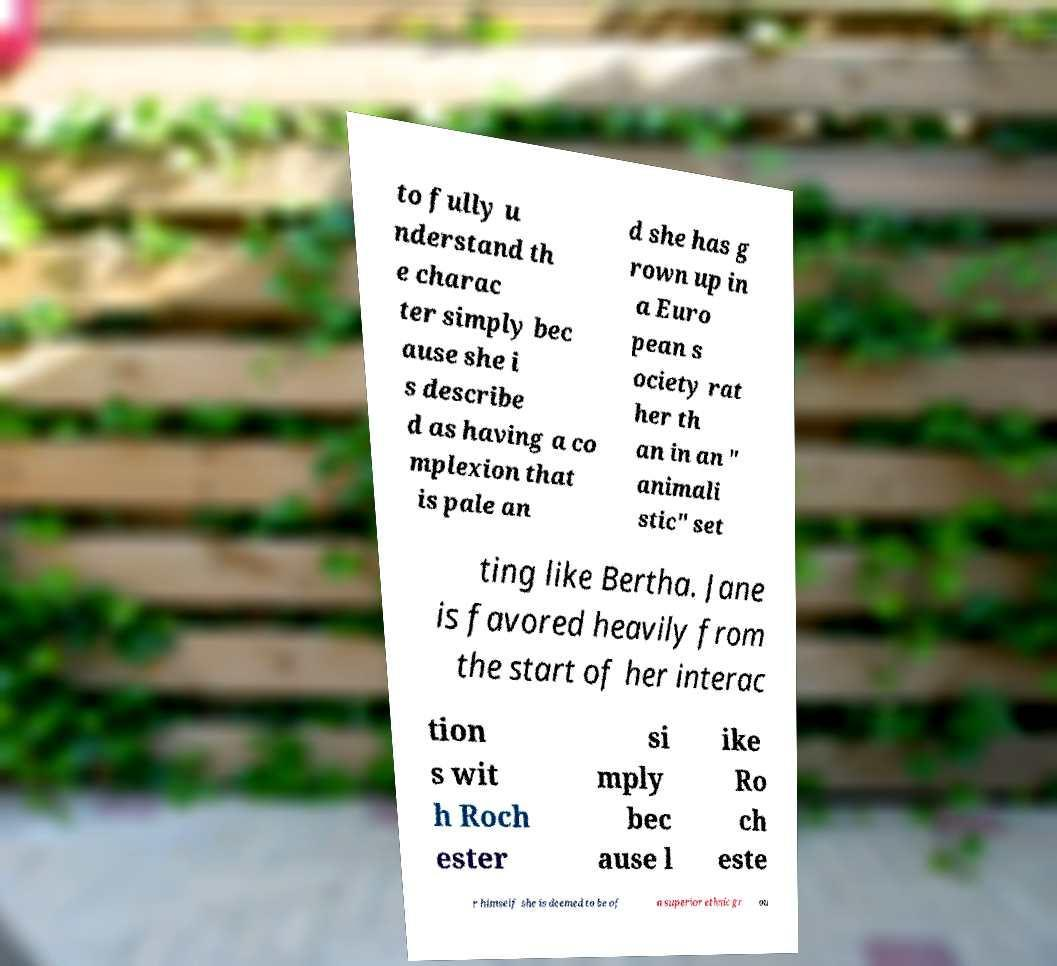Could you assist in decoding the text presented in this image and type it out clearly? to fully u nderstand th e charac ter simply bec ause she i s describe d as having a co mplexion that is pale an d she has g rown up in a Euro pean s ociety rat her th an in an " animali stic" set ting like Bertha. Jane is favored heavily from the start of her interac tion s wit h Roch ester si mply bec ause l ike Ro ch este r himself she is deemed to be of a superior ethnic gr ou 